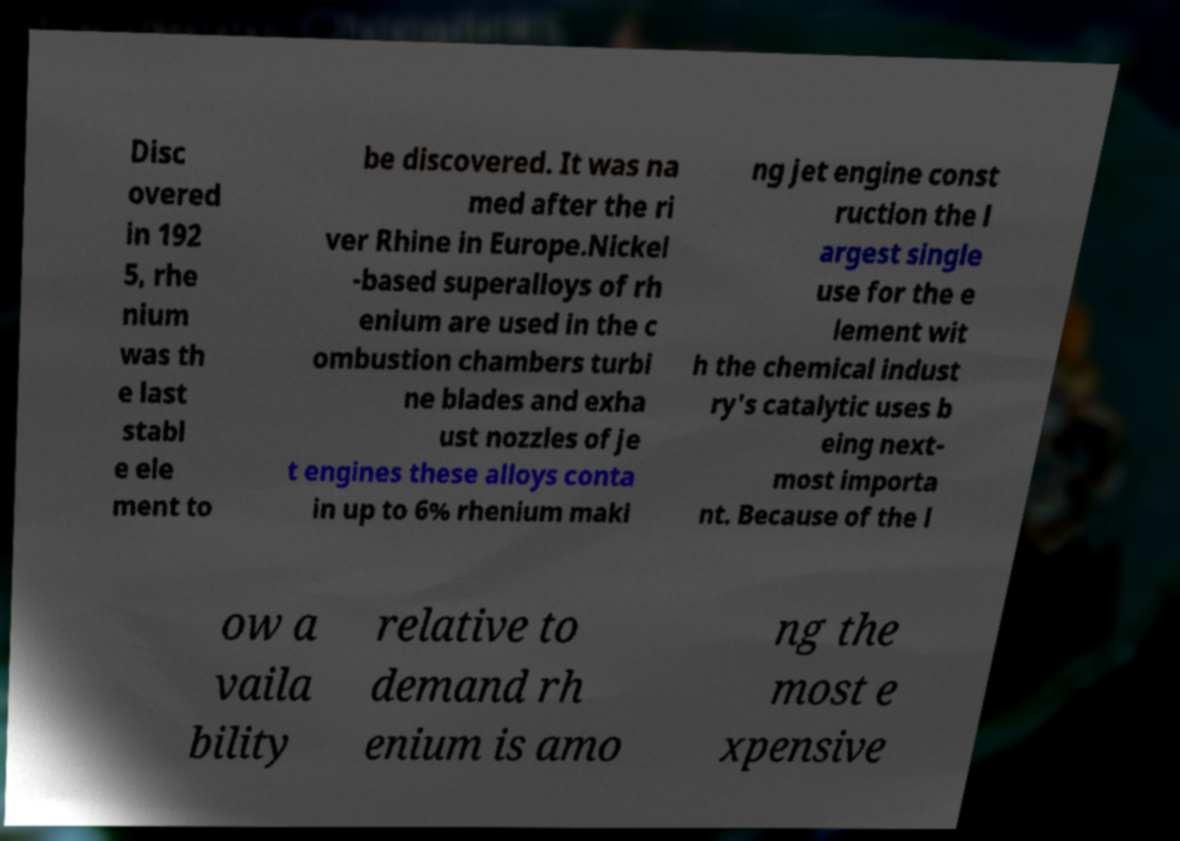Please identify and transcribe the text found in this image. Disc overed in 192 5, rhe nium was th e last stabl e ele ment to be discovered. It was na med after the ri ver Rhine in Europe.Nickel -based superalloys of rh enium are used in the c ombustion chambers turbi ne blades and exha ust nozzles of je t engines these alloys conta in up to 6% rhenium maki ng jet engine const ruction the l argest single use for the e lement wit h the chemical indust ry's catalytic uses b eing next- most importa nt. Because of the l ow a vaila bility relative to demand rh enium is amo ng the most e xpensive 